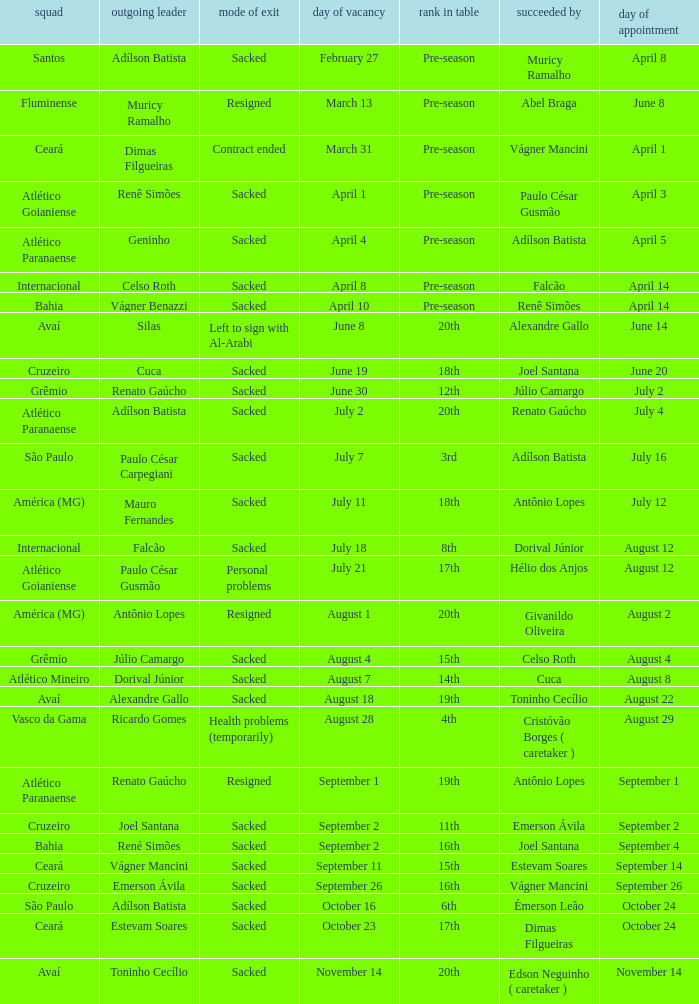Write the full table. {'header': ['squad', 'outgoing leader', 'mode of exit', 'day of vacancy', 'rank in table', 'succeeded by', 'day of appointment'], 'rows': [['Santos', 'Adílson Batista', 'Sacked', 'February 27', 'Pre-season', 'Muricy Ramalho', 'April 8'], ['Fluminense', 'Muricy Ramalho', 'Resigned', 'March 13', 'Pre-season', 'Abel Braga', 'June 8'], ['Ceará', 'Dimas Filgueiras', 'Contract ended', 'March 31', 'Pre-season', 'Vágner Mancini', 'April 1'], ['Atlético Goianiense', 'Renê Simões', 'Sacked', 'April 1', 'Pre-season', 'Paulo César Gusmão', 'April 3'], ['Atlético Paranaense', 'Geninho', 'Sacked', 'April 4', 'Pre-season', 'Adílson Batista', 'April 5'], ['Internacional', 'Celso Roth', 'Sacked', 'April 8', 'Pre-season', 'Falcão', 'April 14'], ['Bahia', 'Vágner Benazzi', 'Sacked', 'April 10', 'Pre-season', 'Renê Simões', 'April 14'], ['Avaí', 'Silas', 'Left to sign with Al-Arabi', 'June 8', '20th', 'Alexandre Gallo', 'June 14'], ['Cruzeiro', 'Cuca', 'Sacked', 'June 19', '18th', 'Joel Santana', 'June 20'], ['Grêmio', 'Renato Gaúcho', 'Sacked', 'June 30', '12th', 'Júlio Camargo', 'July 2'], ['Atlético Paranaense', 'Adílson Batista', 'Sacked', 'July 2', '20th', 'Renato Gaúcho', 'July 4'], ['São Paulo', 'Paulo César Carpegiani', 'Sacked', 'July 7', '3rd', 'Adílson Batista', 'July 16'], ['América (MG)', 'Mauro Fernandes', 'Sacked', 'July 11', '18th', 'Antônio Lopes', 'July 12'], ['Internacional', 'Falcão', 'Sacked', 'July 18', '8th', 'Dorival Júnior', 'August 12'], ['Atlético Goianiense', 'Paulo César Gusmão', 'Personal problems', 'July 21', '17th', 'Hélio dos Anjos', 'August 12'], ['América (MG)', 'Antônio Lopes', 'Resigned', 'August 1', '20th', 'Givanildo Oliveira', 'August 2'], ['Grêmio', 'Júlio Camargo', 'Sacked', 'August 4', '15th', 'Celso Roth', 'August 4'], ['Atlético Mineiro', 'Dorival Júnior', 'Sacked', 'August 7', '14th', 'Cuca', 'August 8'], ['Avaí', 'Alexandre Gallo', 'Sacked', 'August 18', '19th', 'Toninho Cecílio', 'August 22'], ['Vasco da Gama', 'Ricardo Gomes', 'Health problems (temporarily)', 'August 28', '4th', 'Cristóvão Borges ( caretaker )', 'August 29'], ['Atlético Paranaense', 'Renato Gaúcho', 'Resigned', 'September 1', '19th', 'Antônio Lopes', 'September 1'], ['Cruzeiro', 'Joel Santana', 'Sacked', 'September 2', '11th', 'Emerson Ávila', 'September 2'], ['Bahia', 'René Simões', 'Sacked', 'September 2', '16th', 'Joel Santana', 'September 4'], ['Ceará', 'Vágner Mancini', 'Sacked', 'September 11', '15th', 'Estevam Soares', 'September 14'], ['Cruzeiro', 'Emerson Ávila', 'Sacked', 'September 26', '16th', 'Vágner Mancini', 'September 26'], ['São Paulo', 'Adílson Batista', 'Sacked', 'October 16', '6th', 'Émerson Leão', 'October 24'], ['Ceará', 'Estevam Soares', 'Sacked', 'October 23', '17th', 'Dimas Filgueiras', 'October 24'], ['Avaí', 'Toninho Cecílio', 'Sacked', 'November 14', '20th', 'Edson Neguinho ( caretaker )', 'November 14']]} Why did Geninho leave as manager? Sacked. 